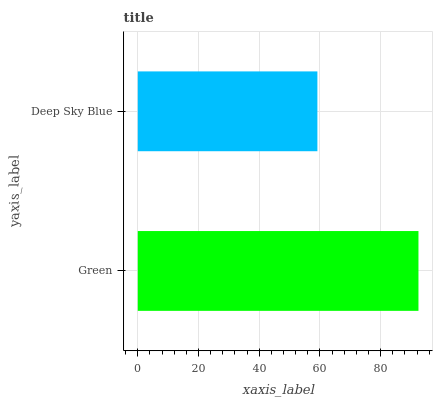Is Deep Sky Blue the minimum?
Answer yes or no. Yes. Is Green the maximum?
Answer yes or no. Yes. Is Deep Sky Blue the maximum?
Answer yes or no. No. Is Green greater than Deep Sky Blue?
Answer yes or no. Yes. Is Deep Sky Blue less than Green?
Answer yes or no. Yes. Is Deep Sky Blue greater than Green?
Answer yes or no. No. Is Green less than Deep Sky Blue?
Answer yes or no. No. Is Green the high median?
Answer yes or no. Yes. Is Deep Sky Blue the low median?
Answer yes or no. Yes. Is Deep Sky Blue the high median?
Answer yes or no. No. Is Green the low median?
Answer yes or no. No. 